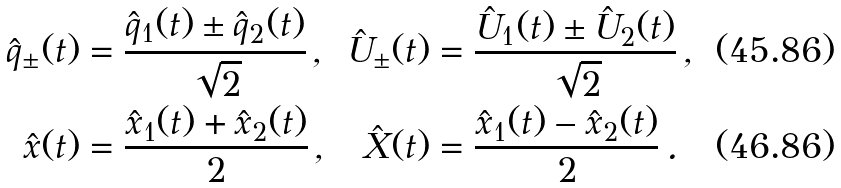<formula> <loc_0><loc_0><loc_500><loc_500>\hat { q } _ { \pm } ( t ) & = \frac { \hat { q } _ { 1 } ( t ) \pm \hat { q } _ { 2 } ( t ) } { \sqrt { 2 } } \, , & \hat { U } _ { \pm } ( t ) & = \frac { \hat { U } _ { 1 } ( t ) \pm \hat { U } _ { 2 } ( t ) } { \sqrt { 2 } } \, , \\ \hat { x } ( t ) & = \frac { \hat { x } _ { 1 } ( t ) + \hat { x } _ { 2 } ( t ) } { 2 } \, , & \hat { X } ( t ) & = \frac { \hat { x } _ { 1 } ( t ) - \hat { x } _ { 2 } ( t ) } { 2 } \, .</formula> 